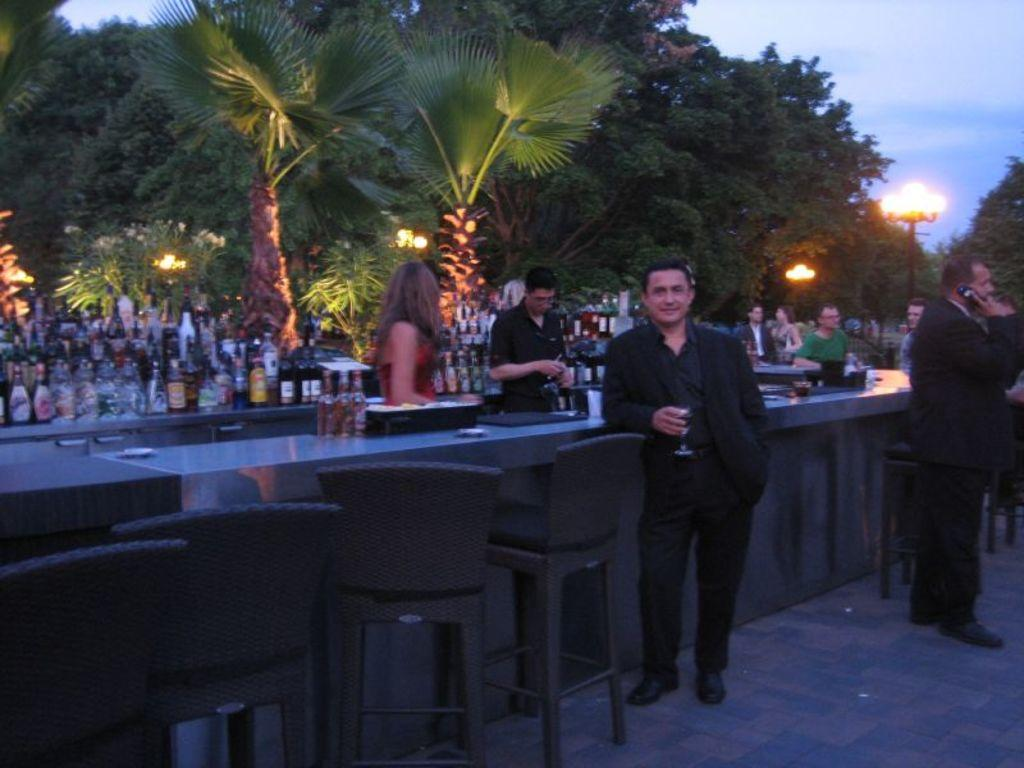What type of furniture is in the image? There is a long desk in the image. What is on the desk? There are things placed on the desk. Are there any people in the image? Yes, there are people standing around the desk. What type of seating is present in the image? There are chairs in the image. Can you see any snakes slithering through the fog in the image? There is no fog or snakes present in the image. 